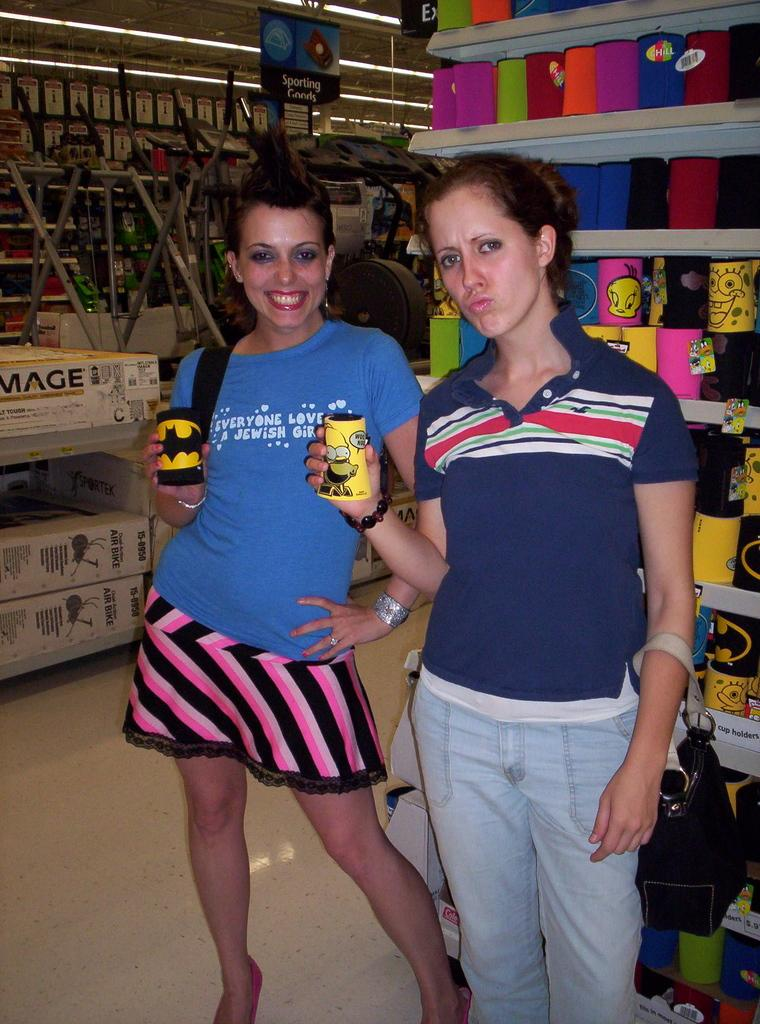<image>
Write a terse but informative summary of the picture. Two women, one of whom wears a tee shirt reading Everyone Loves a Jewish Girl. 